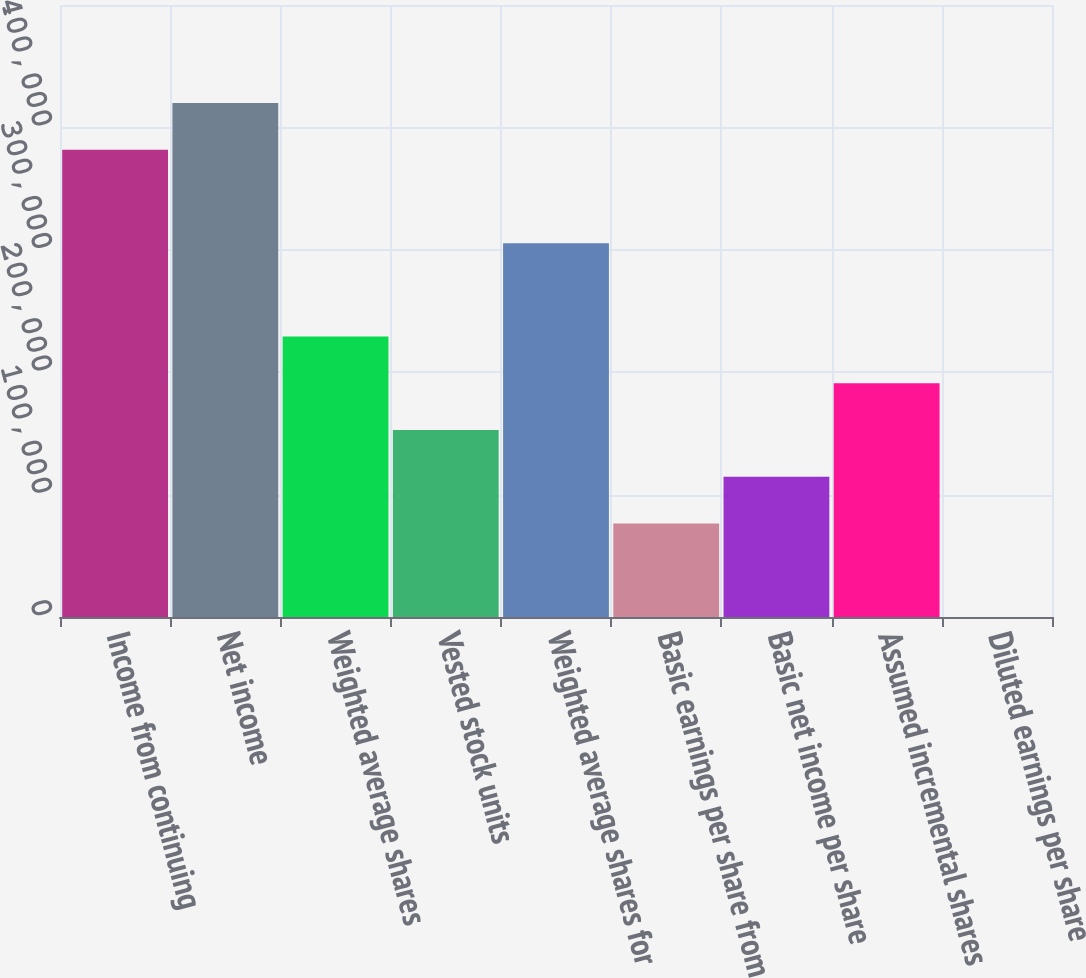<chart> <loc_0><loc_0><loc_500><loc_500><bar_chart><fcel>Income from continuing<fcel>Net income<fcel>Weighted average shares<fcel>Vested stock units<fcel>Weighted average shares for<fcel>Basic earnings per share from<fcel>Basic net income per share<fcel>Assumed incremental shares<fcel>Diluted earnings per share<nl><fcel>381778<fcel>419955<fcel>229068<fcel>152713<fcel>305423<fcel>76358.4<fcel>114536<fcel>190891<fcel>3.55<nl></chart> 